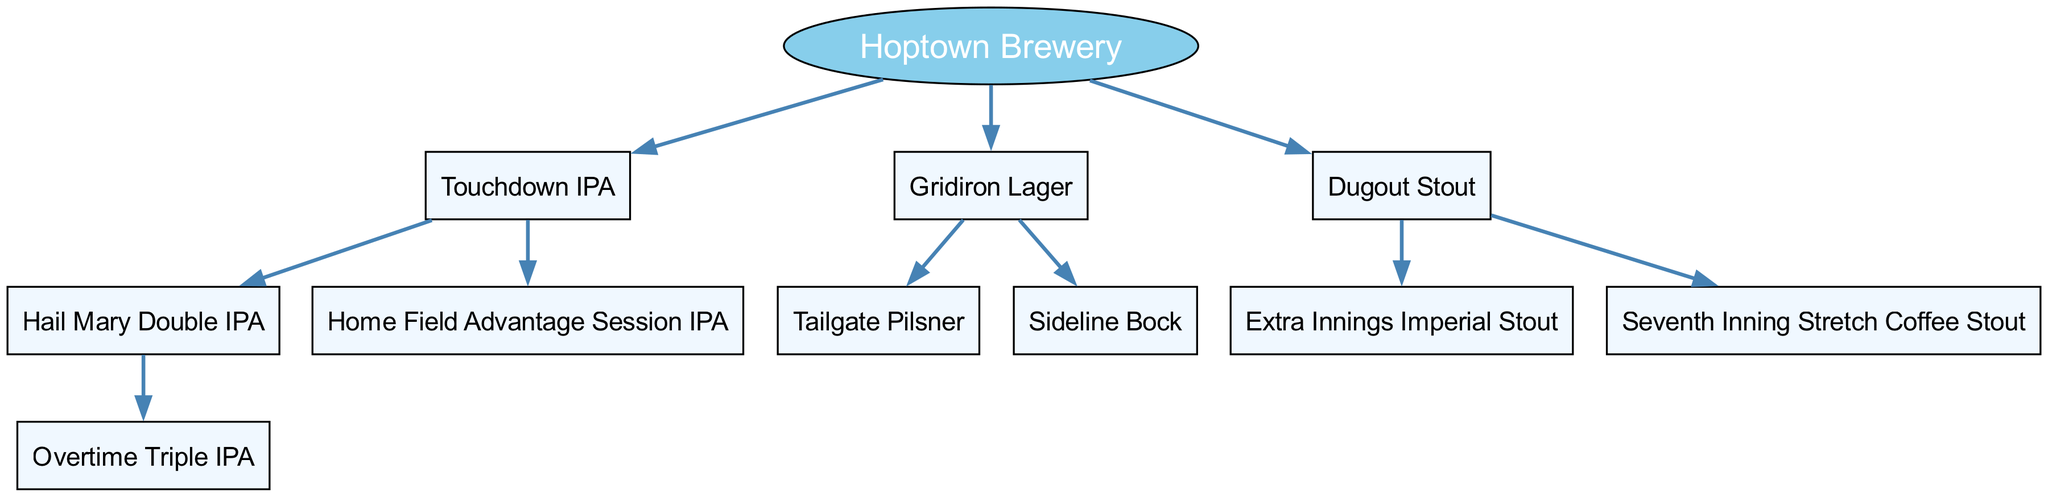What is the root of the craft beer family tree? The root node of the diagram is "Hoptown Brewery". This is indicated as the primary node from which all other nodes branch out.
Answer: Hoptown Brewery How many types of IPAs are listed under Hoptown Brewery? There are three types of IPAs listed: "Touchdown IPA", "Hail Mary Double IPA", and "Home Field Advantage Session IPA". This can be deduced by counting the relevant nodes under the IPA category.
Answer: 3 What is the name of the child brewed from the Touchdown IPA? The child brewed from the "Touchdown IPA" is "Hail Mary Double IPA", which directly connects as its child node in the diagram.
Answer: Hail Mary Double IPA Which beer is a descendant of the Dugout Stout? "Extra Innings Imperial Stout" and "Seventh Inning Stretch Coffee Stout" are both descendants of "Dugout Stout", as they are directly linked under this parent node.
Answer: Extra Innings Imperial Stout, Seventh Inning Stretch Coffee Stout How many total beers are listed under Hoptown Brewery? To find the total number of beers, we count all unique nodes: "Hoptown Brewery", "Touchdown IPA", "Hail Mary Double IPA", "Overtime Triple IPA", "Home Field Advantage Session IPA", "Gridiron Lager", "Tailgate Pilsner", "Sideline Bock", "Dugout Stout", "Extra Innings Imperial Stout", and "Seventh Inning Stretch Coffee Stout". This totals to 11.
Answer: 11 Which lager is listed under Hoptown Brewery? The beer listed under the lager category is "Gridiron Lager", which appears as a direct child of the main root.
Answer: Gridiron Lager What type of stout has a coffee variant in Hoptown Brewery? The stout that has a coffee variant is "Dugout Stout", which has the specific variant "Seventh Inning Stretch Coffee Stout" as one of its children.
Answer: Dugout Stout What is the parent of the Overtime Triple IPA? The parent of "Overtime Triple IPA" is "Hail Mary Double IPA", as depicted in the diagram showing this direct lineage.
Answer: Hail Mary Double IPA 